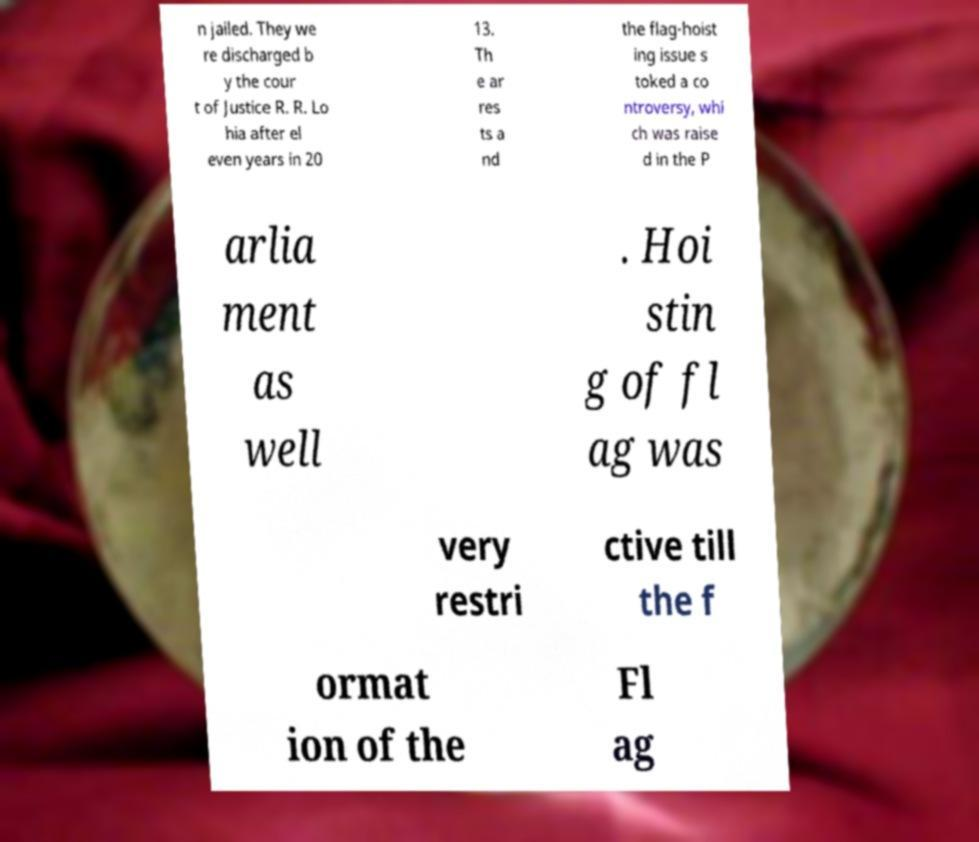Can you read and provide the text displayed in the image?This photo seems to have some interesting text. Can you extract and type it out for me? n jailed. They we re discharged b y the cour t of Justice R. R. Lo hia after el even years in 20 13. Th e ar res ts a nd the flag-hoist ing issue s toked a co ntroversy, whi ch was raise d in the P arlia ment as well . Hoi stin g of fl ag was very restri ctive till the f ormat ion of the Fl ag 